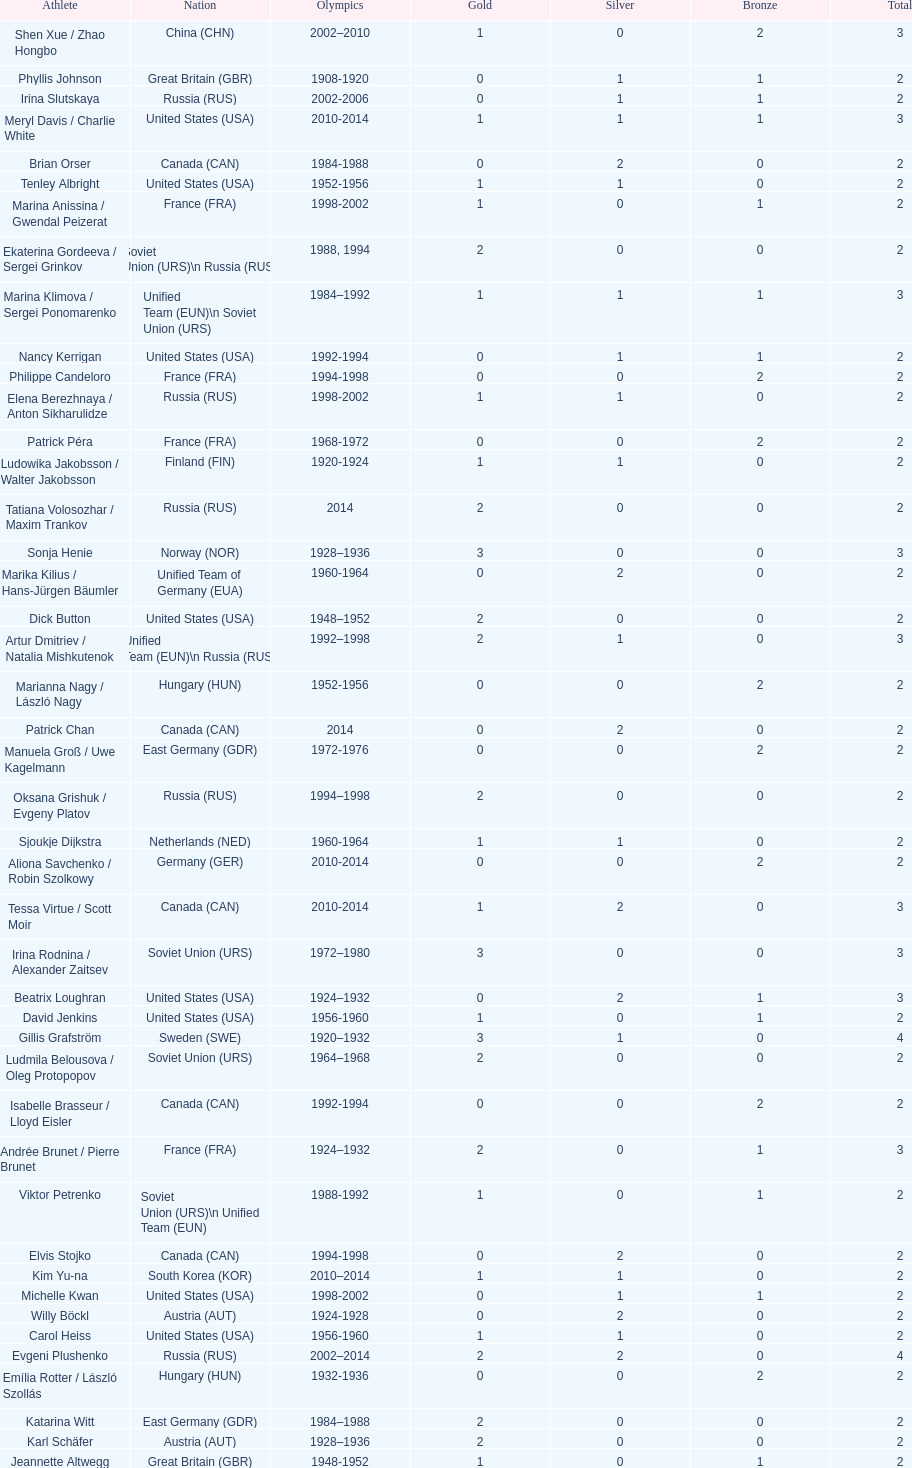Which nation was the first to win three gold medals for olympic figure skating? Sweden. 